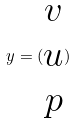Convert formula to latex. <formula><loc_0><loc_0><loc_500><loc_500>y = ( \begin{matrix} v \\ u \\ p \end{matrix} )</formula> 